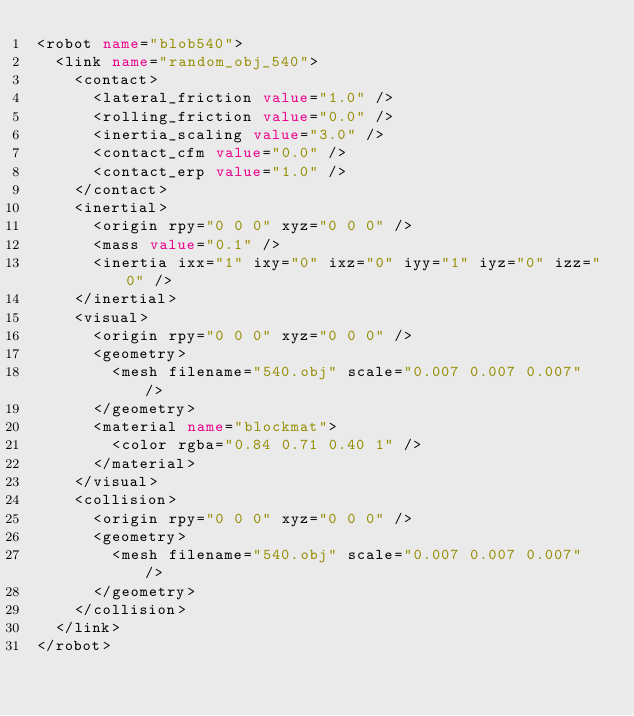Convert code to text. <code><loc_0><loc_0><loc_500><loc_500><_XML_><robot name="blob540">
  <link name="random_obj_540">
    <contact>
      <lateral_friction value="1.0" />
      <rolling_friction value="0.0" />
      <inertia_scaling value="3.0" />
      <contact_cfm value="0.0" />
      <contact_erp value="1.0" />
    </contact>
    <inertial>
      <origin rpy="0 0 0" xyz="0 0 0" />
      <mass value="0.1" />
      <inertia ixx="1" ixy="0" ixz="0" iyy="1" iyz="0" izz="0" />
    </inertial>
    <visual>
      <origin rpy="0 0 0" xyz="0 0 0" />
      <geometry>
        <mesh filename="540.obj" scale="0.007 0.007 0.007" />
      </geometry>
      <material name="blockmat">
        <color rgba="0.84 0.71 0.40 1" />
      </material>
    </visual>
    <collision>
      <origin rpy="0 0 0" xyz="0 0 0" />
      <geometry>
        <mesh filename="540.obj" scale="0.007 0.007 0.007" />
      </geometry>
    </collision>
  </link>
</robot></code> 